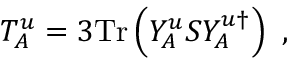<formula> <loc_0><loc_0><loc_500><loc_500>T _ { A } ^ { u } = 3 T r \left ( Y _ { A } ^ { u } S Y _ { A } ^ { u \dagger } \right ) \ ,</formula> 